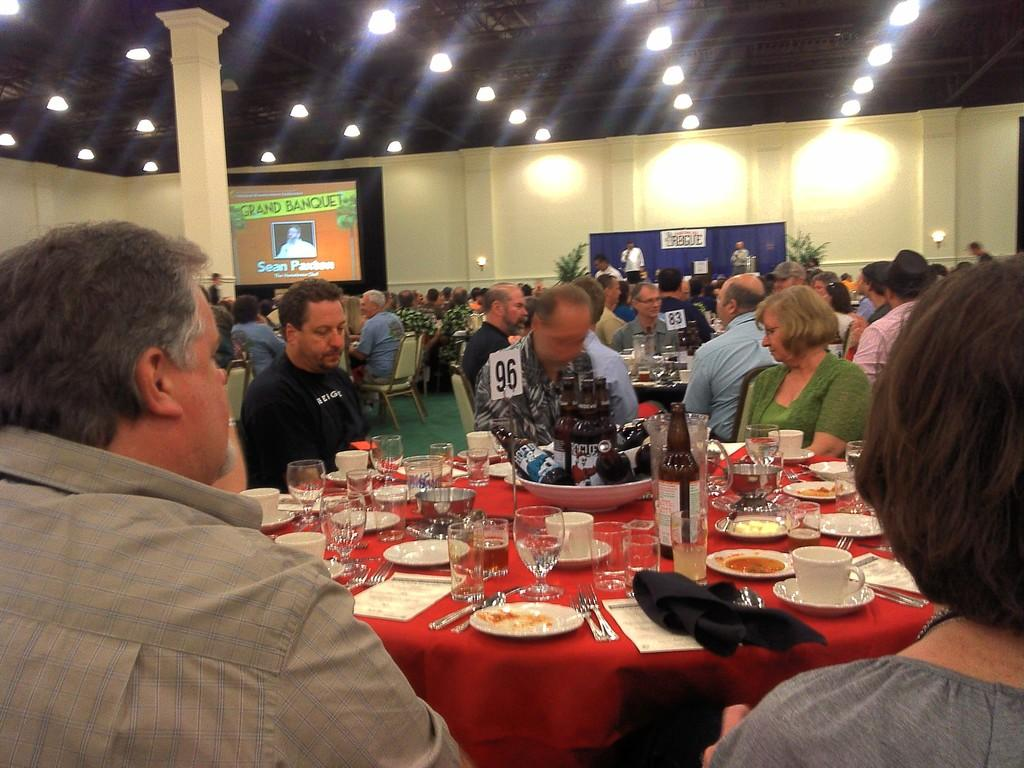Who is present in the image? There are people in the image. How are the people arranged in the image? The people are sitting in groups. Where are the people sitting in the image? The people are at tables. What type of event might be taking place based on the image? The setting appears to be a party. What type of insect can be seen crawling on the people's heads in the image? There are no insects present in the image; the people's heads are not shown. 